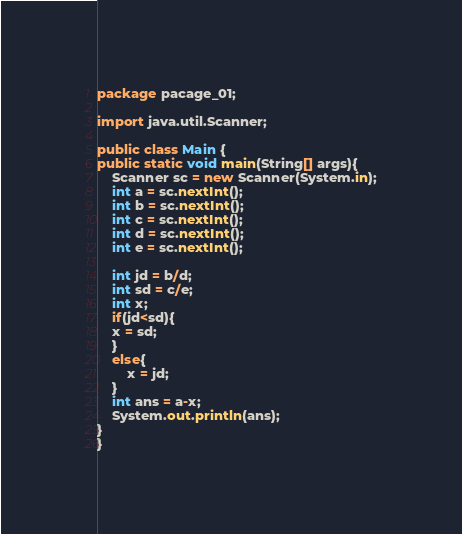Convert code to text. <code><loc_0><loc_0><loc_500><loc_500><_Java_>package pacage_01;

import java.util.Scanner;

public class Main {
public static void main(String[] args){
	Scanner sc = new Scanner(System.in);
	int a = sc.nextInt();
	int b = sc.nextInt();
	int c = sc.nextInt();
	int d = sc.nextInt();
	int e = sc.nextInt();
	
	int jd = b/d;
	int sd = c/e;
	int x;
	if(jd<sd){
	x = sd;	
	}
	else{
		x = jd;
	}
	int ans = a-x;
	System.out.println(ans);
}
}</code> 